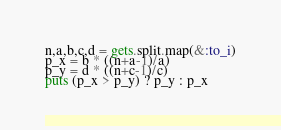Convert code to text. <code><loc_0><loc_0><loc_500><loc_500><_Ruby_>n,a,b,c,d = gets.split.map(&:to_i)
p_x = b * ((n+a-1)/a)
p_y = d * ((n+c-1)/c)
puts (p_x > p_y) ? p_y : p_x
</code> 